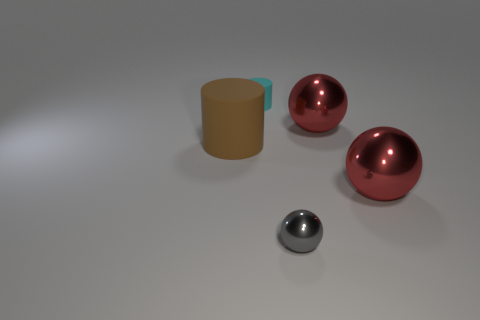Subtract all purple cylinders. Subtract all yellow blocks. How many cylinders are left? 2 Subtract all gray spheres. How many blue cylinders are left? 0 Add 4 tiny cyans. How many big browns exist? 0 Subtract all small cyan objects. Subtract all yellow metallic cubes. How many objects are left? 4 Add 1 cylinders. How many cylinders are left? 3 Add 2 cylinders. How many cylinders exist? 4 Add 1 purple metal cubes. How many objects exist? 6 Subtract all cyan cylinders. How many cylinders are left? 1 Subtract all small balls. How many balls are left? 2 Subtract 0 purple balls. How many objects are left? 5 